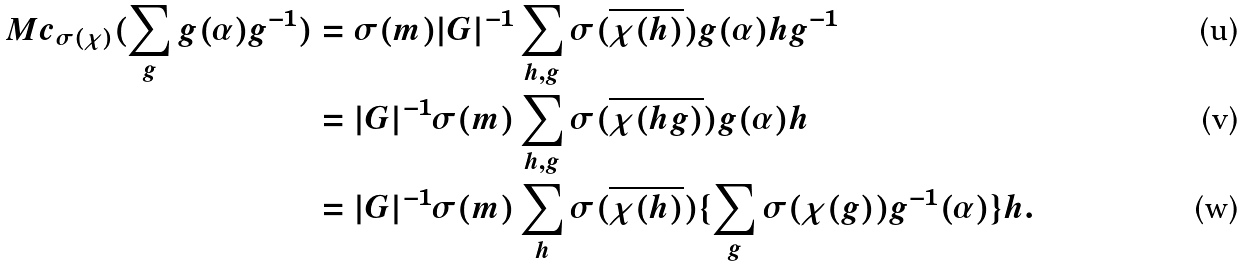Convert formula to latex. <formula><loc_0><loc_0><loc_500><loc_500>M c _ { \sigma ( \chi ) } ( \sum _ { g } g ( \alpha ) g ^ { - 1 } ) & = \sigma ( m ) | G | ^ { - 1 } \sum _ { h , g } \sigma ( \overline { \chi ( h ) } ) g ( \alpha ) h g ^ { - 1 } \\ & = | G | ^ { - 1 } \sigma ( m ) \sum _ { h , g } \sigma ( \overline { \chi ( h g ) } ) g ( \alpha ) h \\ & = | G | ^ { - 1 } \sigma ( m ) \sum _ { h } \sigma ( \overline { \chi ( h ) } ) \{ \sum _ { g } \sigma ( { \chi ( g ) } ) g ^ { - 1 } ( \alpha ) \} h .</formula> 